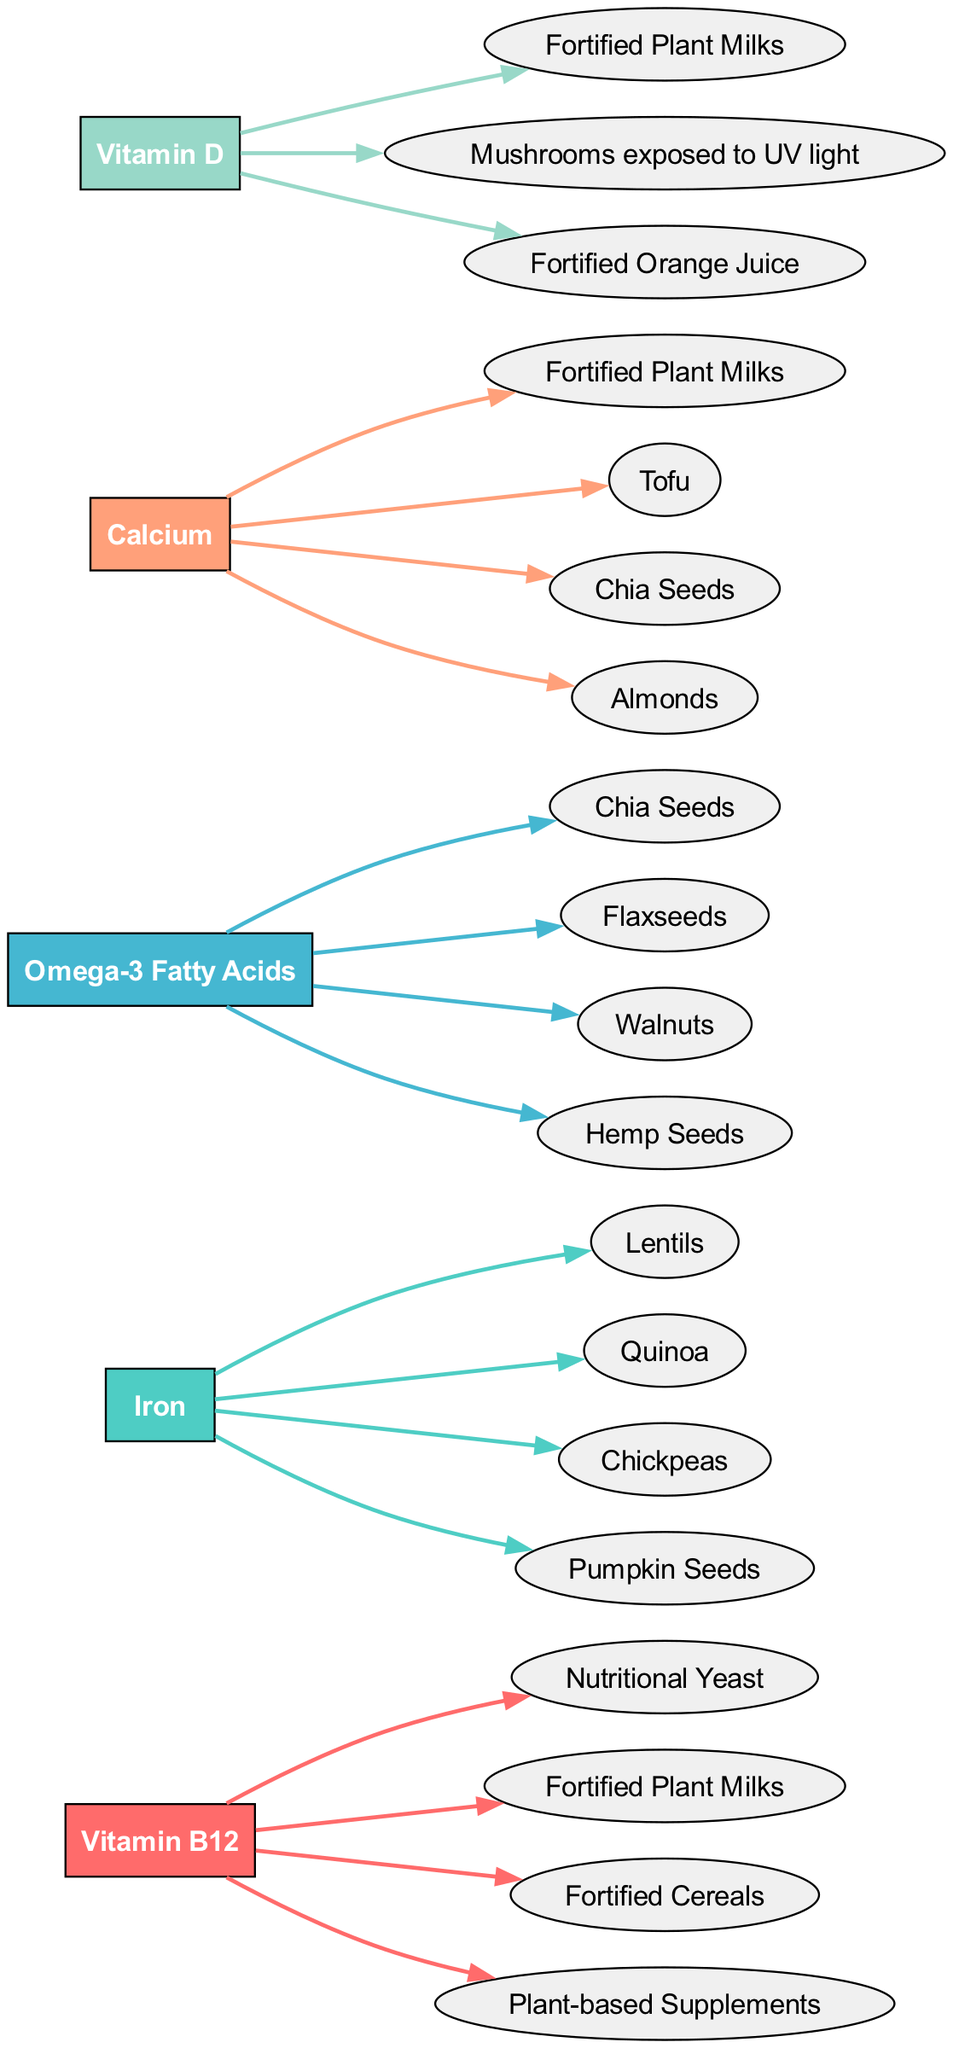What are the food sources for Vitamin B12? From the diagram, we can see the deficiency node for Vitamin B12 connected to its food sources. The food sources listed under Vitamin B12 are Nutritional Yeast, Fortified Plant Milks, Fortified Cereals, and Plant-based Supplements.
Answer: Nutritional Yeast, Fortified Plant Milks, Fortified Cereals, Plant-based Supplements How many food sources are associated with Calcium? The Calcium deficiency node is shown as having connections to four food sources: Fortified Plant Milks, Tofu, Chia Seeds, and Almonds. By counting these connections, we can determine that there are four food sources associated with Calcium.
Answer: 4 Which deficiency has the food source of Flaxseeds? Looking at the diagram, we can see that Flaxseeds are connected to the deficiency node for Omega-3 Fatty Acids, indicating that this specific deficiency has Flaxseeds as one of its food sources.
Answer: Omega-3 Fatty Acids Which food sources are common for both Calcium and Omega-3 Fatty Acids? By examining the food sources connected to both the Calcium and Omega-3 Fatty Acids deficiency nodes, we find that the food source Chia Seeds appears under both deficiencies. This indicates that Chia Seeds can provide benefits for both deficiencies.
Answer: Chia Seeds What color is used for the Vitamin D deficiency node? The node color for Vitamin D is determined by the given color palette in the diagram. Vitamin D corresponds to the fifth index in the color list, which is represented by the color #98D8C8. Thus, the Vitamin D deficiency node is colored accordingly.
Answer: #98D8C8 How many deficiencies are represented in total? The diagram shows a total of five deficiency nodes: Vitamin B12, Iron, Omega-3 Fatty Acids, Calcium, and Vitamin D. By counting these, we can confirm that there are five deficiencies represented in the diagram.
Answer: 5 What type of shape is used for the food source nodes? From the diagram’s design, we can see that all food source nodes are represented with an ellipse shape. The visual representation indicates that this specific shape is standard for food source nodes in the diagram.
Answer: Ellipse Which deficiency has the food sources listed in the following order: "Chickpeas, Lentils, Quinoa, Pumpkin Seeds"? By analyzing the diagram, we find that these food sources are all connected to the Iron deficiency node. Therefore, it is the Iron deficiency that has these specific food sources listed in that order.
Answer: Iron 